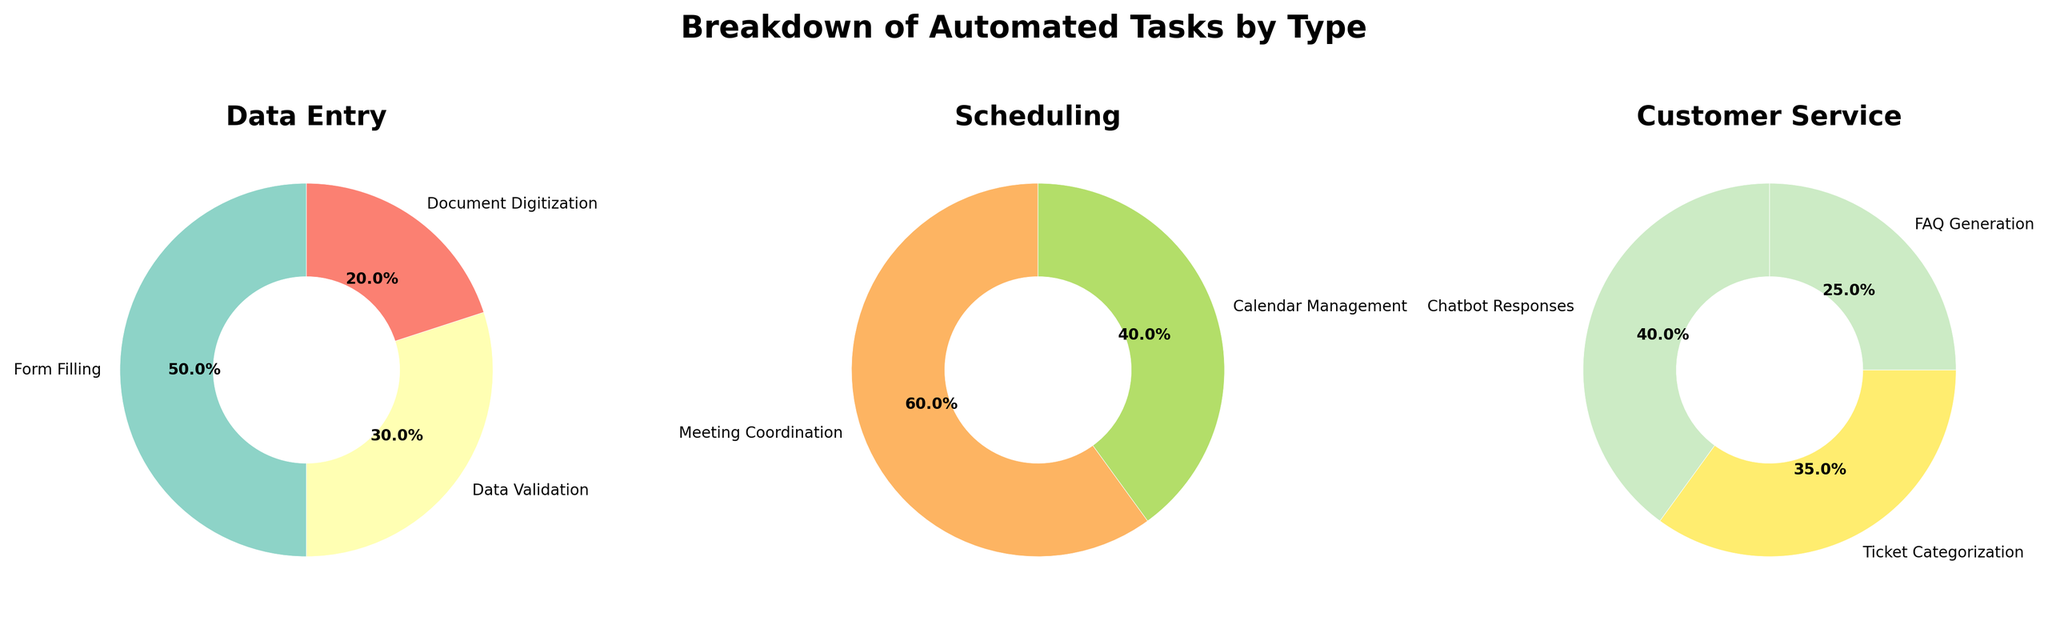What is the title of the figure? The title of the figure is located at the top and often in larger or bold text. It is meant to provide an overview of what the figure represents. The title of this figure is "Breakdown of Automated Tasks by Type."
Answer: Breakdown of Automated Tasks by Type Which category has the highest percentage of automated tasks? To determine this, look at the wedges in each pie chart and compare the percentages. The Data Entry category has the largest wedge with "Form Filling" at 25%.
Answer: Data Entry What is the total percentage of automated tasks in the Scheduling category? Sum the individual percentages of "Meeting Coordination" (18%) and "Calendar Management" (12%). The total percentage is 18% + 12% = 30%.
Answer: 30% Which task has the smallest percentage in the Customer Service category? Look at the wedges for the Customer Service pie chart and identify the smallest percentage. "FAQ Generation" has the smallest wedge at 5%.
Answer: FAQ Generation Compare the percentage of "Data Validation" and "Ticket Categorization." Which one is greater? "Data Validation" has a percentage of 15%, and "Ticket Categorization" has a percentage of 7%. Since 15% is greater than 7%, "Data Validation" has the greater percentage.
Answer: Data Validation What is the combined percentage of all tasks in the Data Entry category? Add the percentages of "Form Filling" (25%), "Data Validation" (15%), and "Document Digitization" (10%). The combined percentage is 25% + 15% + 10% = 50%.
Answer: 50% How many tasks are there in the Scheduling category? Count the number of labeled wedges in the Scheduling pie chart. There are two tasks: "Meeting Coordination" and "Calendar Management."
Answer: 2 Which category has the least number of tasks? Count the labeled wedges in each pie chart for Data Entry, Scheduling, and Customer Service. Customer Service has three tasks, Scheduling has two tasks, and Data Entry has three tasks. Scheduling has the least number of tasks.
Answer: Scheduling What is the average percentage per task in the Customer Service category? To find the average, sum the percentages for "Chatbot Responses" (8%), "Ticket Categorization" (7%), and "FAQ Generation" (5%) and then divide by the number of tasks. The sum is 8% + 7% + 5% = 20%. There are three tasks, so 20% / 3 = approximately 6.67%.
Answer: 6.67% Which pie chart has the highest number of wedges? Count the wedges in each pie chart. Data Entry has three wedges, Scheduling has two wedges, and Customer Service has three wedges. So, Data Entry and Customer Service have the highest number of wedges.
Answer: Data Entry, Customer Service 